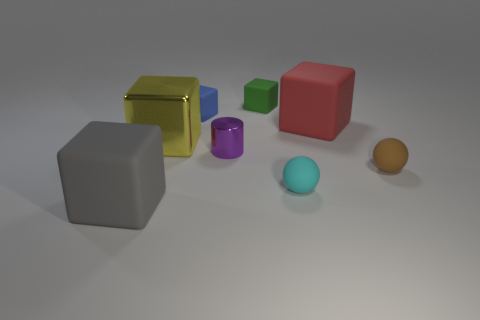How many rubber objects are left of the shiny cylinder?
Your answer should be compact. 2. Are there the same number of green rubber blocks that are left of the small green rubber block and rubber cubes in front of the small blue matte object?
Your response must be concise. No. What is the size of the gray matte thing that is the same shape as the big red matte object?
Your response must be concise. Large. There is a big rubber object to the left of the small cyan ball; what shape is it?
Offer a terse response. Cube. Are the big cube that is right of the small purple thing and the green cube behind the small brown object made of the same material?
Provide a succinct answer. Yes. What is the shape of the yellow metal thing?
Offer a very short reply. Cube. Are there an equal number of gray matte things on the right side of the purple shiny cylinder and large blue metallic cylinders?
Keep it short and to the point. Yes. Is there a tiny brown object made of the same material as the green thing?
Keep it short and to the point. Yes. Is the shape of the large matte thing that is to the left of the big red thing the same as the big rubber thing that is on the right side of the cyan sphere?
Ensure brevity in your answer.  Yes. Are there any large gray rubber blocks?
Ensure brevity in your answer.  Yes. 